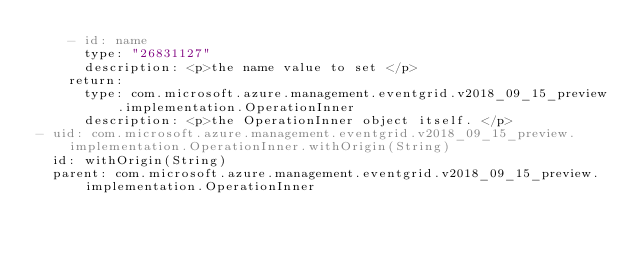Convert code to text. <code><loc_0><loc_0><loc_500><loc_500><_YAML_>    - id: name
      type: "26831127"
      description: <p>the name value to set </p>
    return:
      type: com.microsoft.azure.management.eventgrid.v2018_09_15_preview.implementation.OperationInner
      description: <p>the OperationInner object itself. </p>
- uid: com.microsoft.azure.management.eventgrid.v2018_09_15_preview.implementation.OperationInner.withOrigin(String)
  id: withOrigin(String)
  parent: com.microsoft.azure.management.eventgrid.v2018_09_15_preview.implementation.OperationInner</code> 